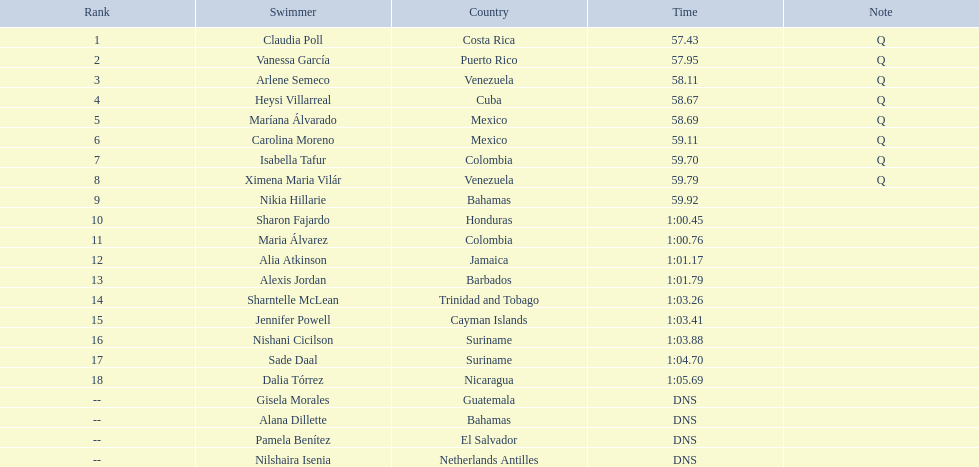Who were the swimmers at the 2006 central american and caribbean games - women's 100 metre freestyle? Claudia Poll, Vanessa García, Arlene Semeco, Heysi Villarreal, Maríana Álvarado, Carolina Moreno, Isabella Tafur, Ximena Maria Vilár, Nikia Hillarie, Sharon Fajardo, Maria Álvarez, Alia Atkinson, Alexis Jordan, Sharntelle McLean, Jennifer Powell, Nishani Cicilson, Sade Daal, Dalia Tórrez, Gisela Morales, Alana Dillette, Pamela Benítez, Nilshaira Isenia. Of these which were from cuba? Heysi Villarreal. 